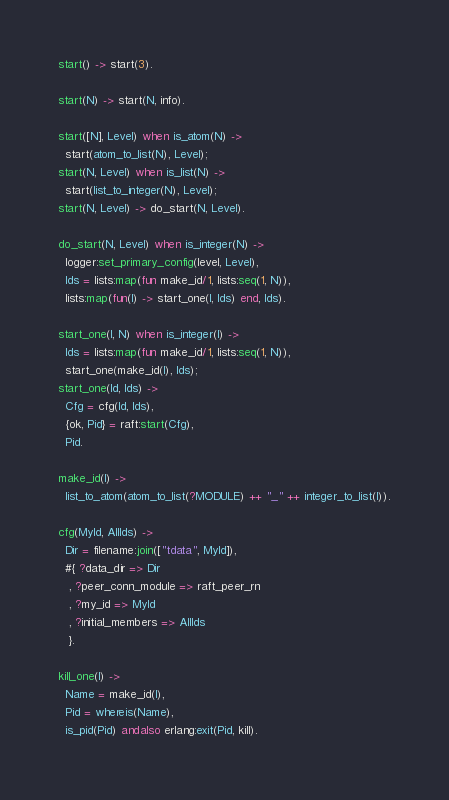Convert code to text. <code><loc_0><loc_0><loc_500><loc_500><_Erlang_>start() -> start(3).

start(N) -> start(N, info).

start([N], Level) when is_atom(N) ->
  start(atom_to_list(N), Level);
start(N, Level) when is_list(N) ->
  start(list_to_integer(N), Level);
start(N, Level) -> do_start(N, Level).

do_start(N, Level) when is_integer(N) ->
  logger:set_primary_config(level, Level),
  Ids = lists:map(fun make_id/1, lists:seq(1, N)),
  lists:map(fun(I) -> start_one(I, Ids) end, Ids).

start_one(I, N) when is_integer(I) ->
  Ids = lists:map(fun make_id/1, lists:seq(1, N)),
  start_one(make_id(I), Ids);
start_one(Id, Ids) ->
  Cfg = cfg(Id, Ids),
  {ok, Pid} = raft:start(Cfg),
  Pid.

make_id(I) ->
  list_to_atom(atom_to_list(?MODULE) ++ "_" ++ integer_to_list(I)).

cfg(MyId, AllIds) ->
  Dir = filename:join(["tdata", MyId]),
  #{ ?data_dir => Dir
   , ?peer_conn_module => raft_peer_rn
   , ?my_id => MyId
   , ?initial_members => AllIds
   }.

kill_one(I) ->
  Name = make_id(I),
  Pid = whereis(Name),
  is_pid(Pid) andalso erlang:exit(Pid, kill).

</code> 